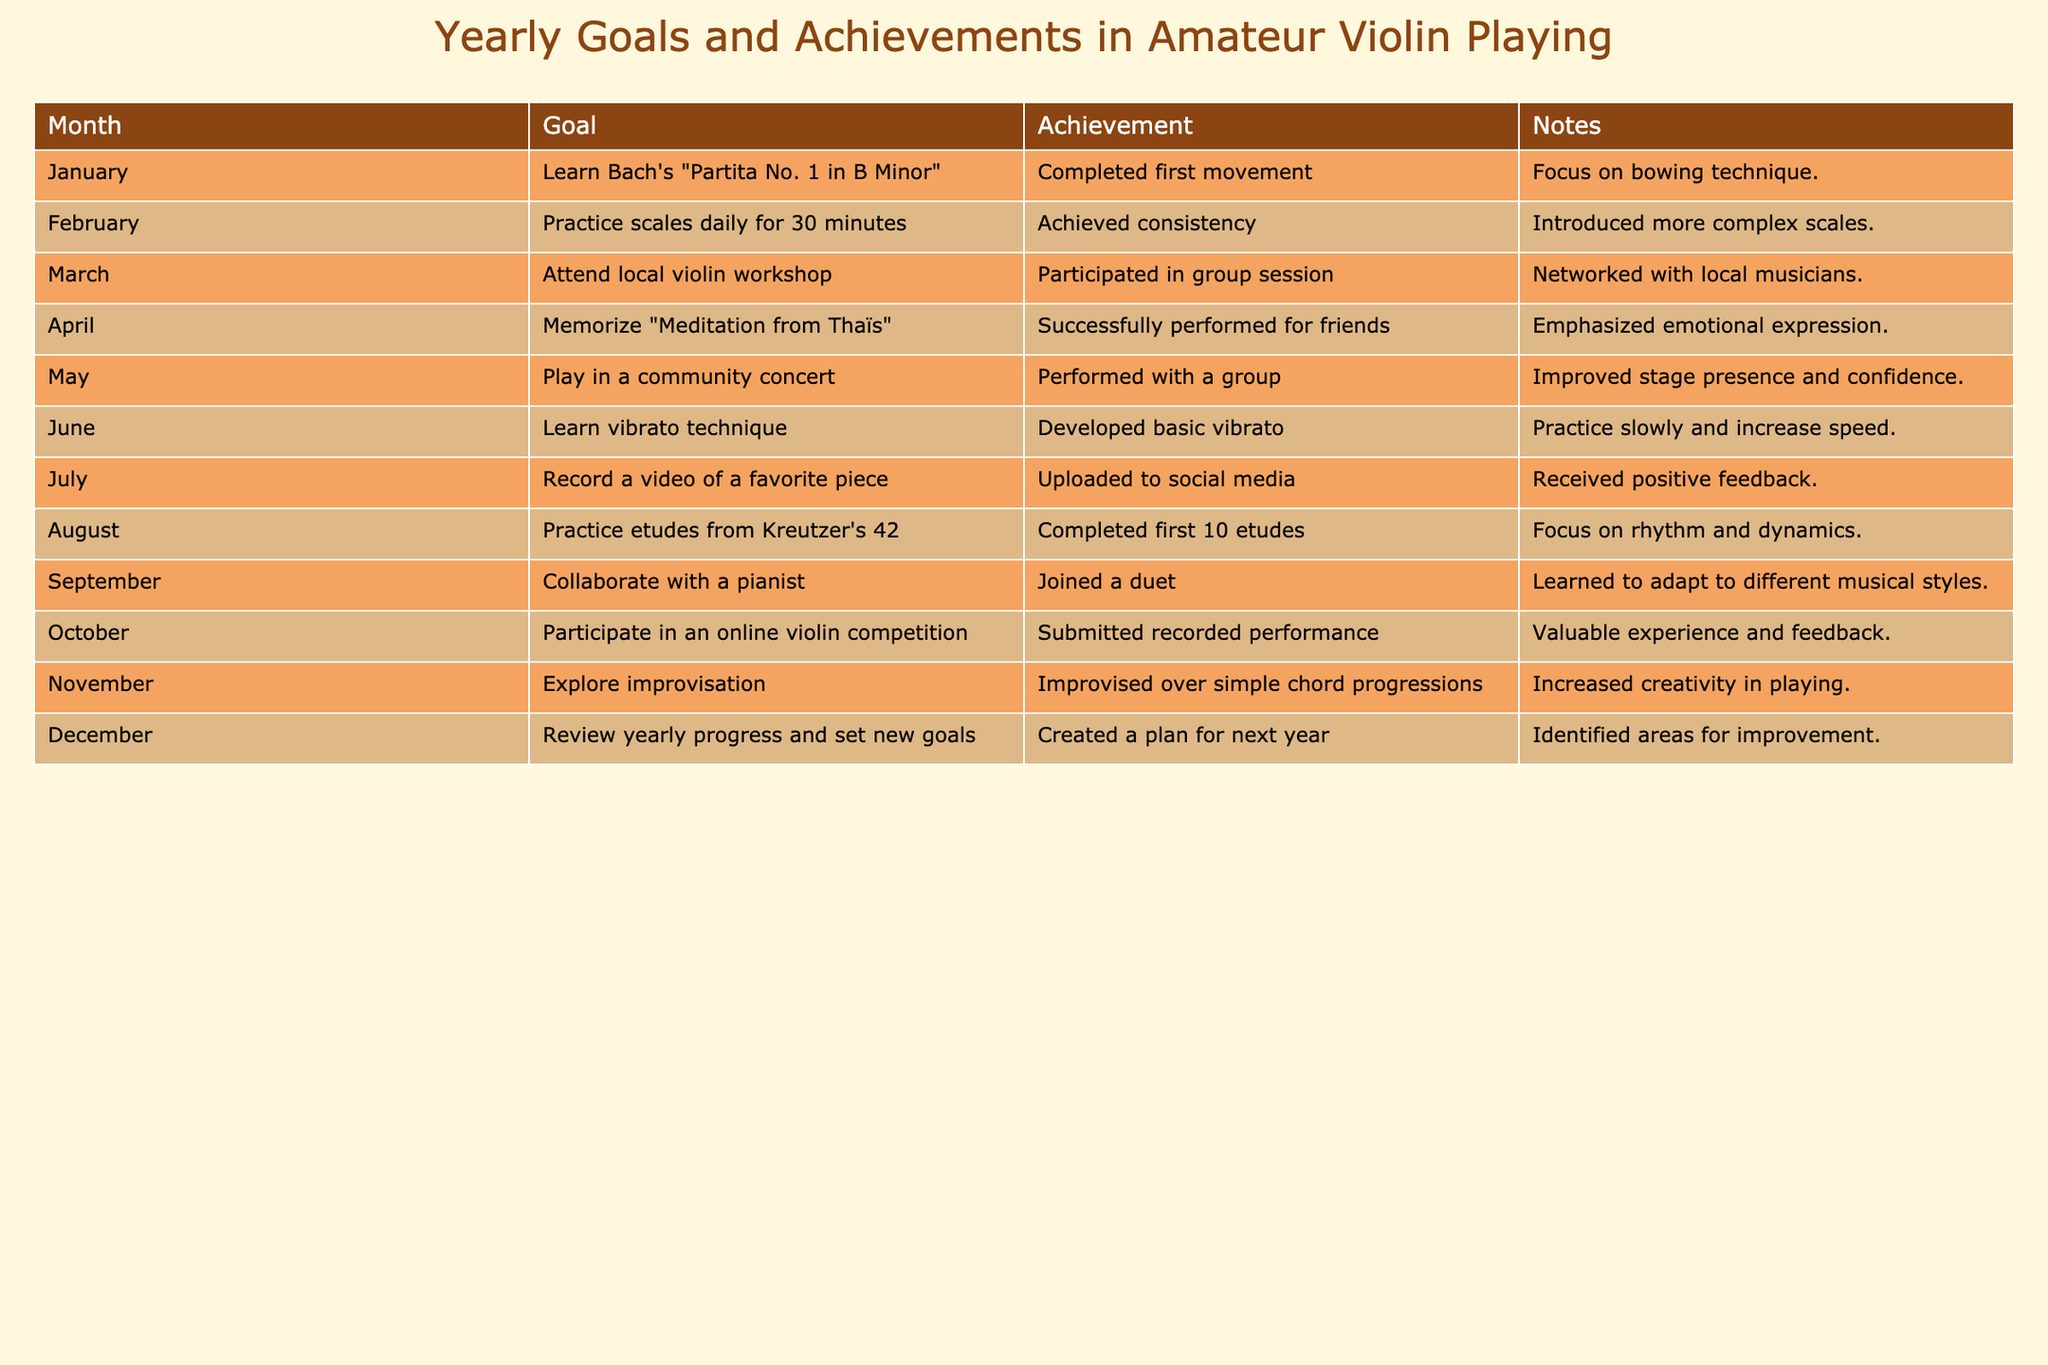What was the goal for May? The goal for May is directly stated in the table under the "Goal" column for that month. It reads: "Play in a community concert."
Answer: Play in a community concert Which two achievements involved performance? By examining the "Achievement" column for the months of April and May, we find both months describe performances: in April, the achievement is "Successfully performed for friends," and in May, it's "Performed with a group."
Answer: April and May How many total pieces did you complete by August? To find the total number of pieces completed, we add the completed movements or pieces listed from January to August: 1 (January) + 1 (February, counted as part of scale practice) + 1 (April) + 1 (May) + 10 (August) = 14.
Answer: 14 Did you learn any new technique in June? By looking at the "Goal" column for June, we see that the goal was "Learn vibrato technique," which indicates a focus on learning a new skill. Therefore, the answer is yes.
Answer: Yes What areas for improvement were identified in December? In December, the notes section states that a plan was created for the next year and areas for improvement were identified. This indicates reflection on past goals. The specific areas are not listed, but it confirms some understanding of what needs work.
Answer: Areas for improvement were identified Which month had the focus on emotional expression? Looking at the "Notes" section for April, it states that the emphasis was on "emotional expression" during the performance of "Meditation from Thaïs."
Answer: April How many months involved collaboration or group activities? From the table, we can identify the months with collaboration or group activities: March (local workshop), May (community concert), and September (duet with a pianist). This results in a total of three months.
Answer: 3 Was there any month where you focused exclusively on technical skills? In June, the goal was solely about learning a new technique ("Learn vibrato technique"), with no mention of performance or collaboration aspects, suggesting an exclusive focus on technical skills.
Answer: Yes What is the total number of specific goals set during the year? By counting all the months listed in the table, we find there were goals set for each of the 12 months in the year, indicating a total of 12 specific goals.
Answer: 12 Which month did you explore a new concept of improvisation? In the table, it states that improvisation was explored during the month of November, indicating an interest in this particular area at that time.
Answer: November 